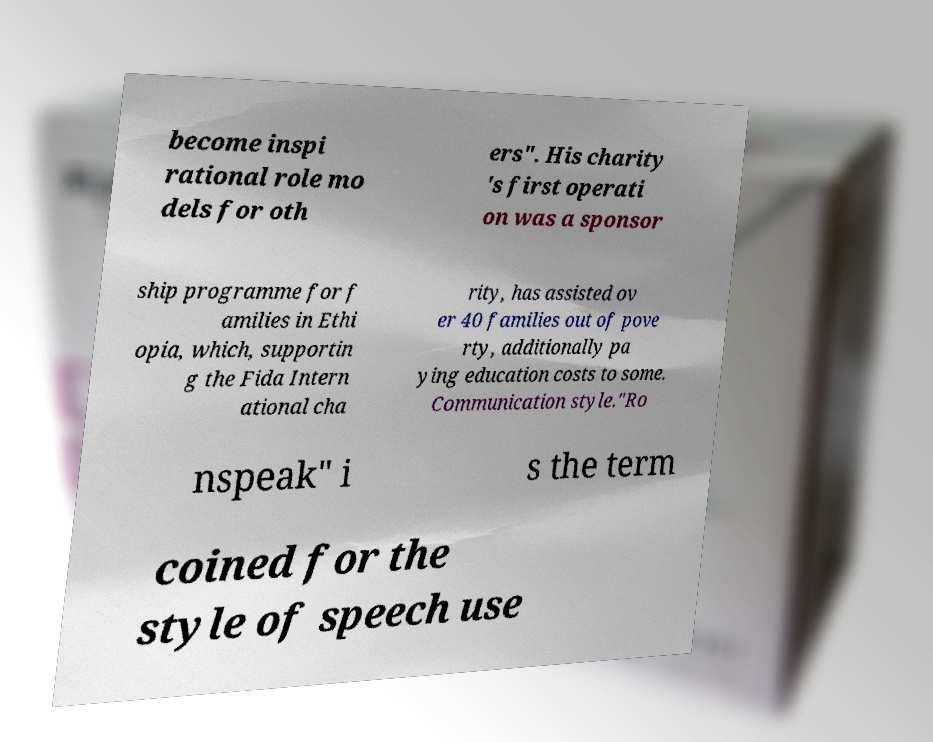What messages or text are displayed in this image? I need them in a readable, typed format. become inspi rational role mo dels for oth ers". His charity 's first operati on was a sponsor ship programme for f amilies in Ethi opia, which, supportin g the Fida Intern ational cha rity, has assisted ov er 40 families out of pove rty, additionally pa ying education costs to some. Communication style."Ro nspeak" i s the term coined for the style of speech use 